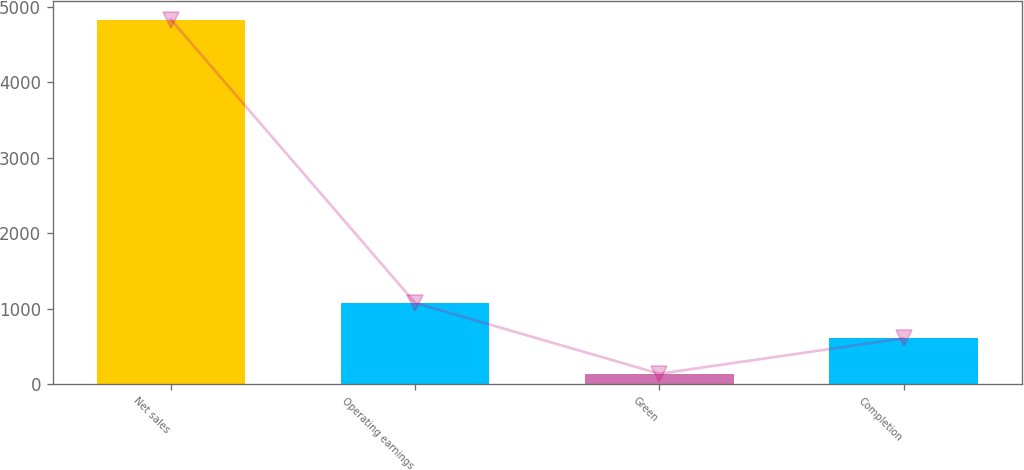Convert chart. <chart><loc_0><loc_0><loc_500><loc_500><bar_chart><fcel>Net sales<fcel>Operating earnings<fcel>Green<fcel>Completion<nl><fcel>4828<fcel>1076<fcel>138<fcel>607<nl></chart> 